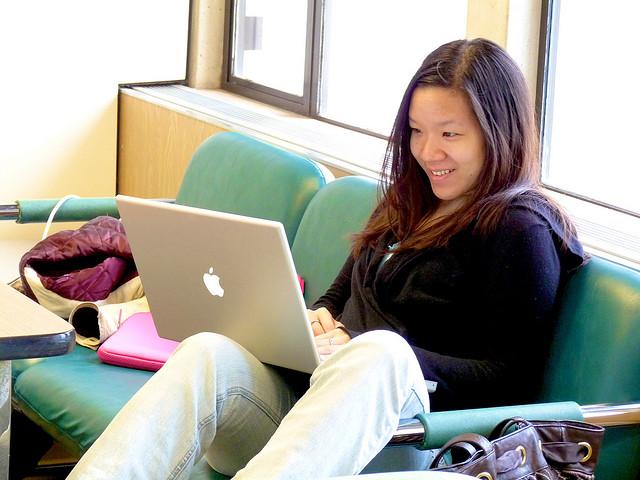What kind of laptop computer does the girl have?
Quick response, please. Apple. Is the laptop on?
Answer briefly. Yes. Where is the girls handbag?
Answer briefly. On her left. 